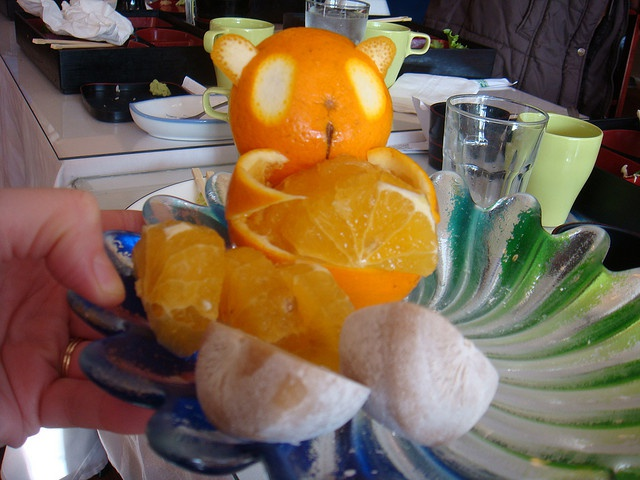Describe the objects in this image and their specific colors. I can see bowl in black, darkgray, and gray tones, people in black, maroon, and brown tones, orange in black, orange, red, and tan tones, orange in black, orange, red, and tan tones, and orange in black, gray, brown, and darkgray tones in this image. 